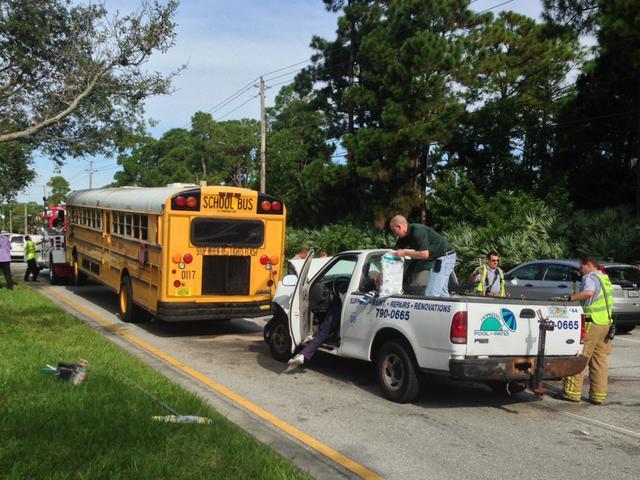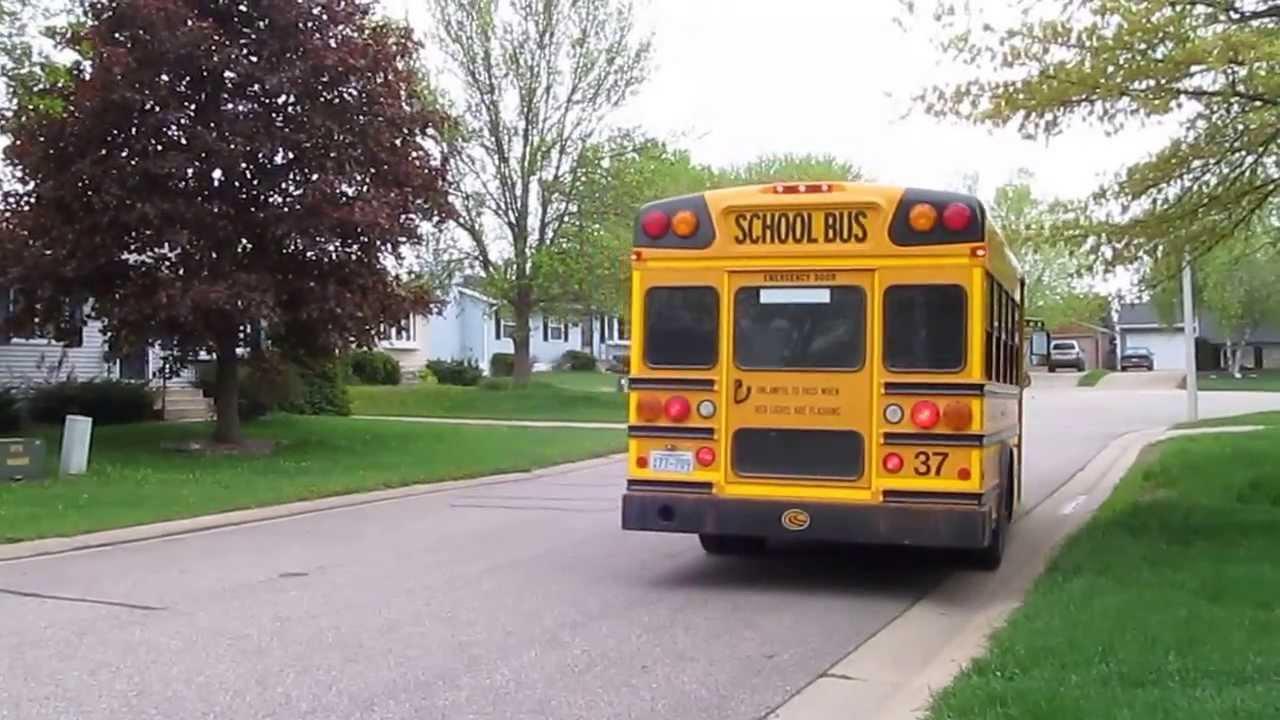The first image is the image on the left, the second image is the image on the right. Considering the images on both sides, is "A child is entering the open door of a school bus parked at a rightward angle in one image, and the other image shows a leftward angled bus." valid? Answer yes or no. No. The first image is the image on the left, the second image is the image on the right. Assess this claim about the two images: "People are getting on the bus.". Correct or not? Answer yes or no. No. 